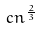<formula> <loc_0><loc_0><loc_500><loc_500>c n ^ { \frac { 2 } { 3 } }</formula> 